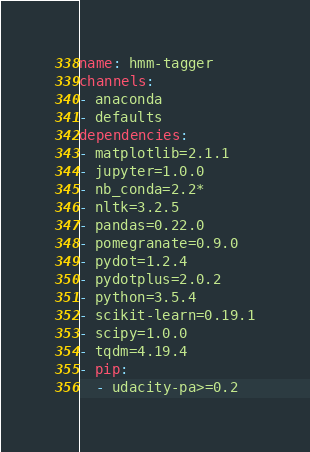Convert code to text. <code><loc_0><loc_0><loc_500><loc_500><_YAML_>name: hmm-tagger
channels:
- anaconda
- defaults
dependencies:
- matplotlib=2.1.1
- jupyter=1.0.0
- nb_conda=2.2*
- nltk=3.2.5
- pandas=0.22.0
- pomegranate=0.9.0
- pydot=1.2.4
- pydotplus=2.0.2
- python=3.5.4
- scikit-learn=0.19.1
- scipy=1.0.0
- tqdm=4.19.4
- pip:
  - udacity-pa>=0.2</code> 